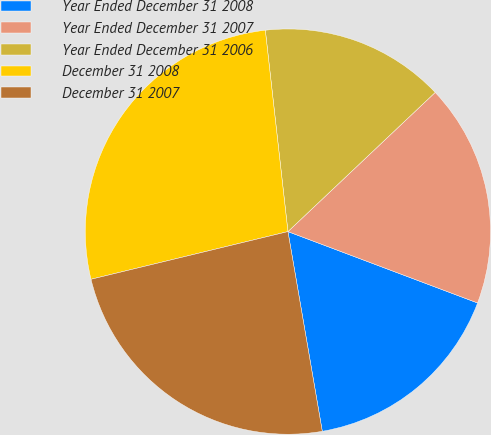Convert chart to OTSL. <chart><loc_0><loc_0><loc_500><loc_500><pie_chart><fcel>Year Ended December 31 2008<fcel>Year Ended December 31 2007<fcel>Year Ended December 31 2006<fcel>December 31 2008<fcel>December 31 2007<nl><fcel>16.56%<fcel>17.78%<fcel>14.73%<fcel>27.0%<fcel>23.93%<nl></chart> 